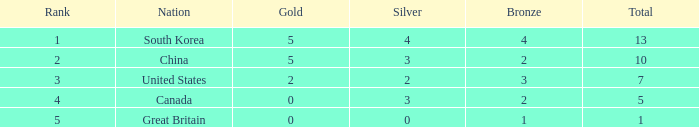If silver is 2 and the total is less than 7, how many gold are there in total? 0.0. 